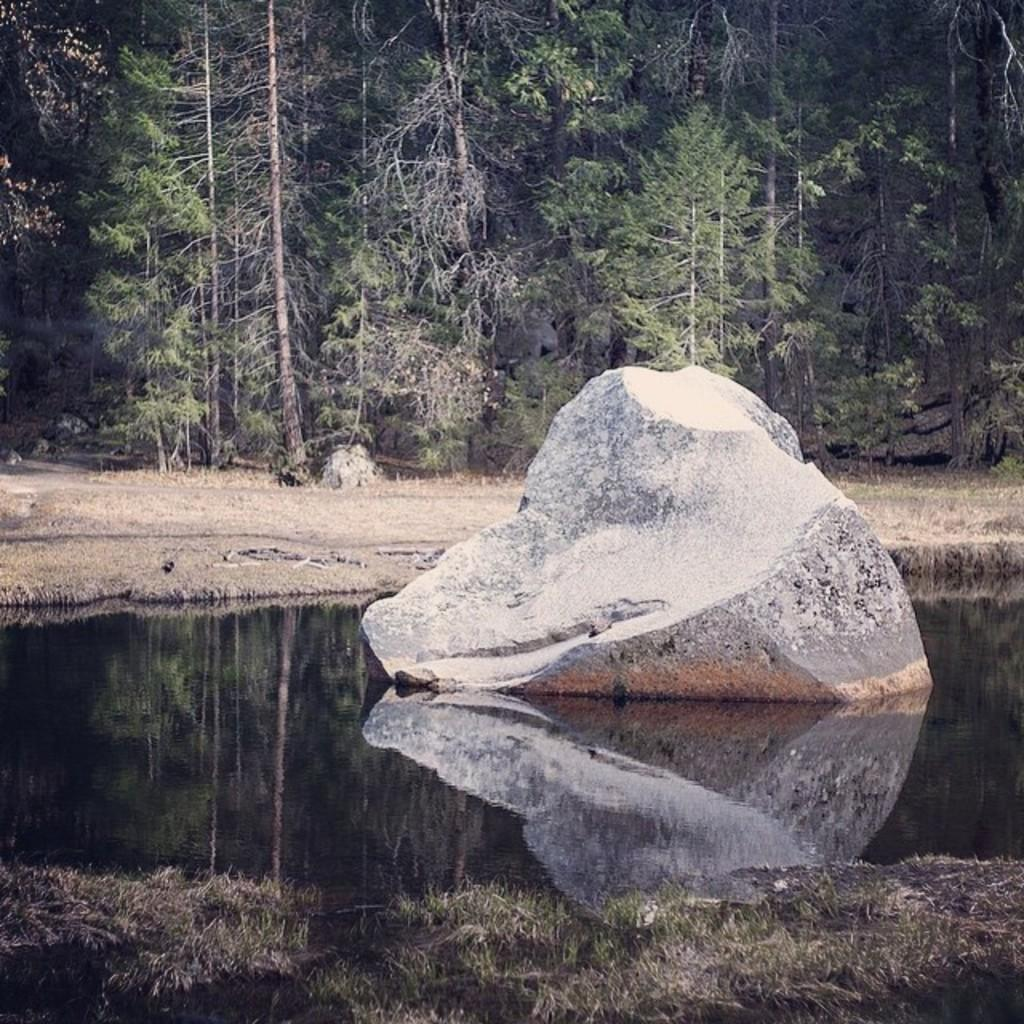What is the main subject in the middle of the image? There is a large stone in the water in the middle of the image. What can be seen in the background of the image? There are trees visible in the background of the image. Where did the stone give birth to its baby stone in the image? There is no mention of a baby stone or any birth in the image; it simply features a large stone in the water. 